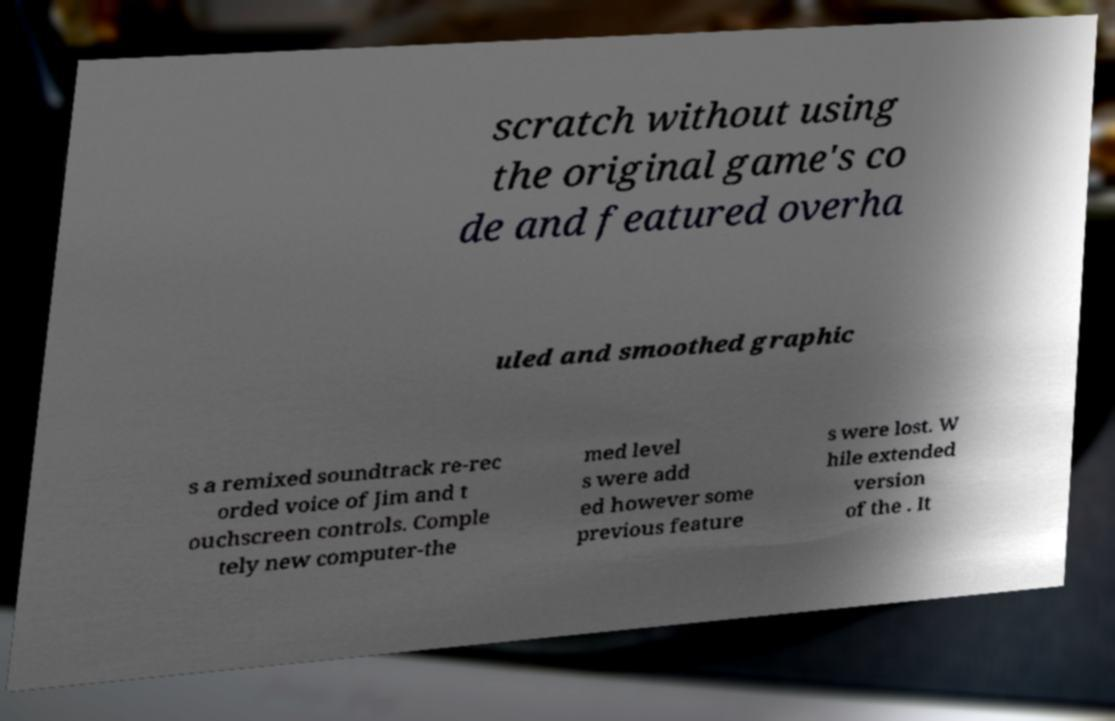There's text embedded in this image that I need extracted. Can you transcribe it verbatim? scratch without using the original game's co de and featured overha uled and smoothed graphic s a remixed soundtrack re-rec orded voice of Jim and t ouchscreen controls. Comple tely new computer-the med level s were add ed however some previous feature s were lost. W hile extended version of the . It 